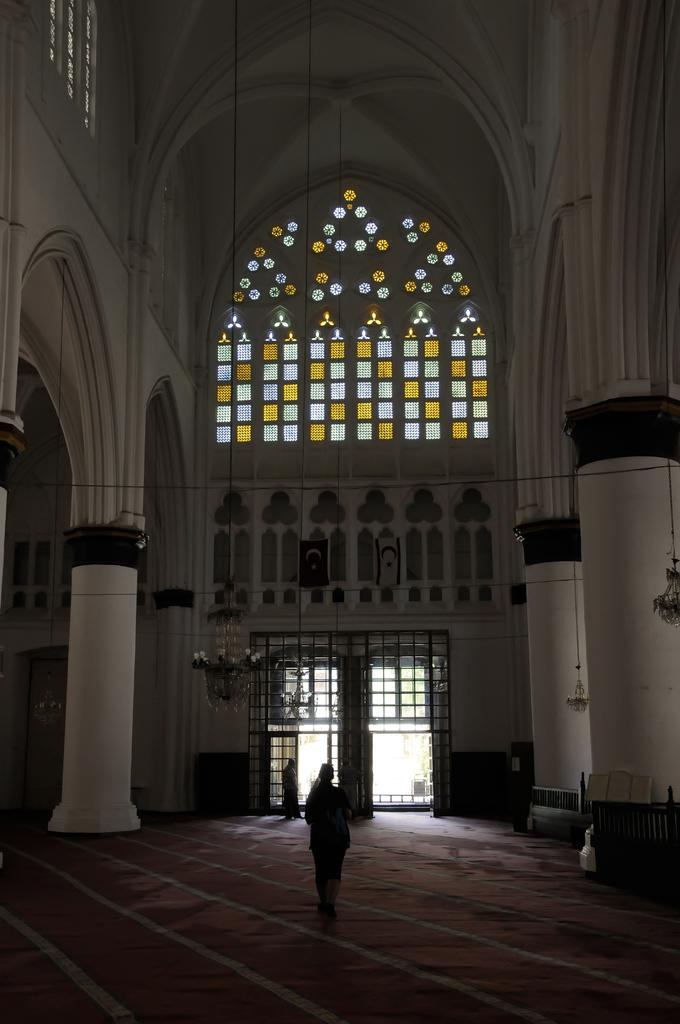What type of location is depicted in the image? The image is an inside view of a building. How many people are present in the image? There are two persons in the image. What architectural features can be seen in the image? There are pillars visible in the image. Is there any entrance or exit visible in the image? Yes, there is a door in the image. What type of line can be seen connecting the two persons in the image? There is no line connecting the two persons in the image. What type of cemetery can be seen in the background of the image? There is no cemetery present in the image; it is an inside view of a building. 